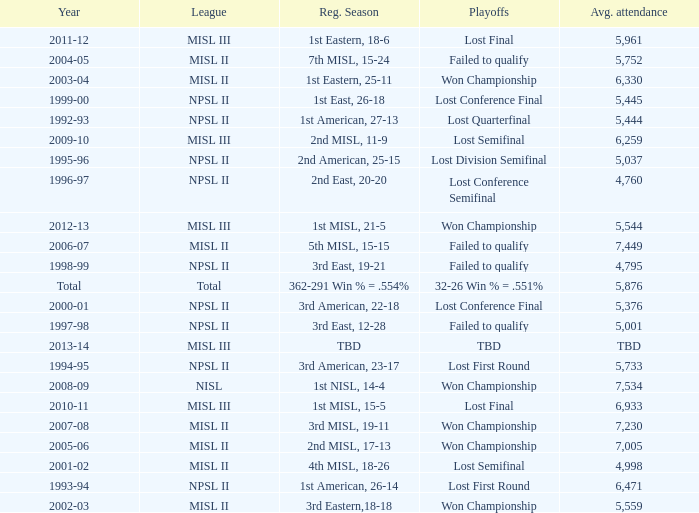In 2010-11, what was the League name? MISL III. 